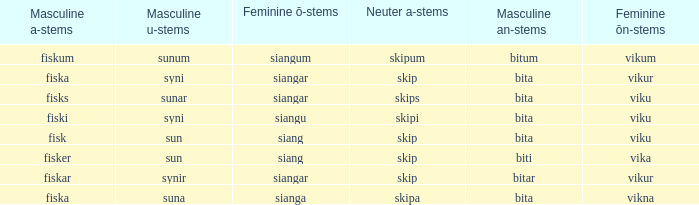What is the manly form for the expression with a feminine ö ending in siangar and a masculine u ending in sunar? Bita. 